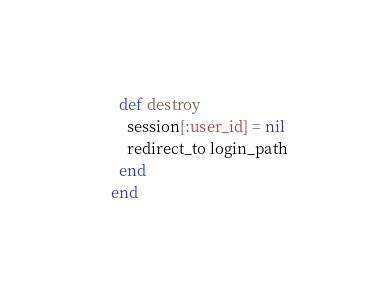Convert code to text. <code><loc_0><loc_0><loc_500><loc_500><_Ruby_>  def destroy
    session[:user_id] = nil
    redirect_to login_path
  end
end</code> 